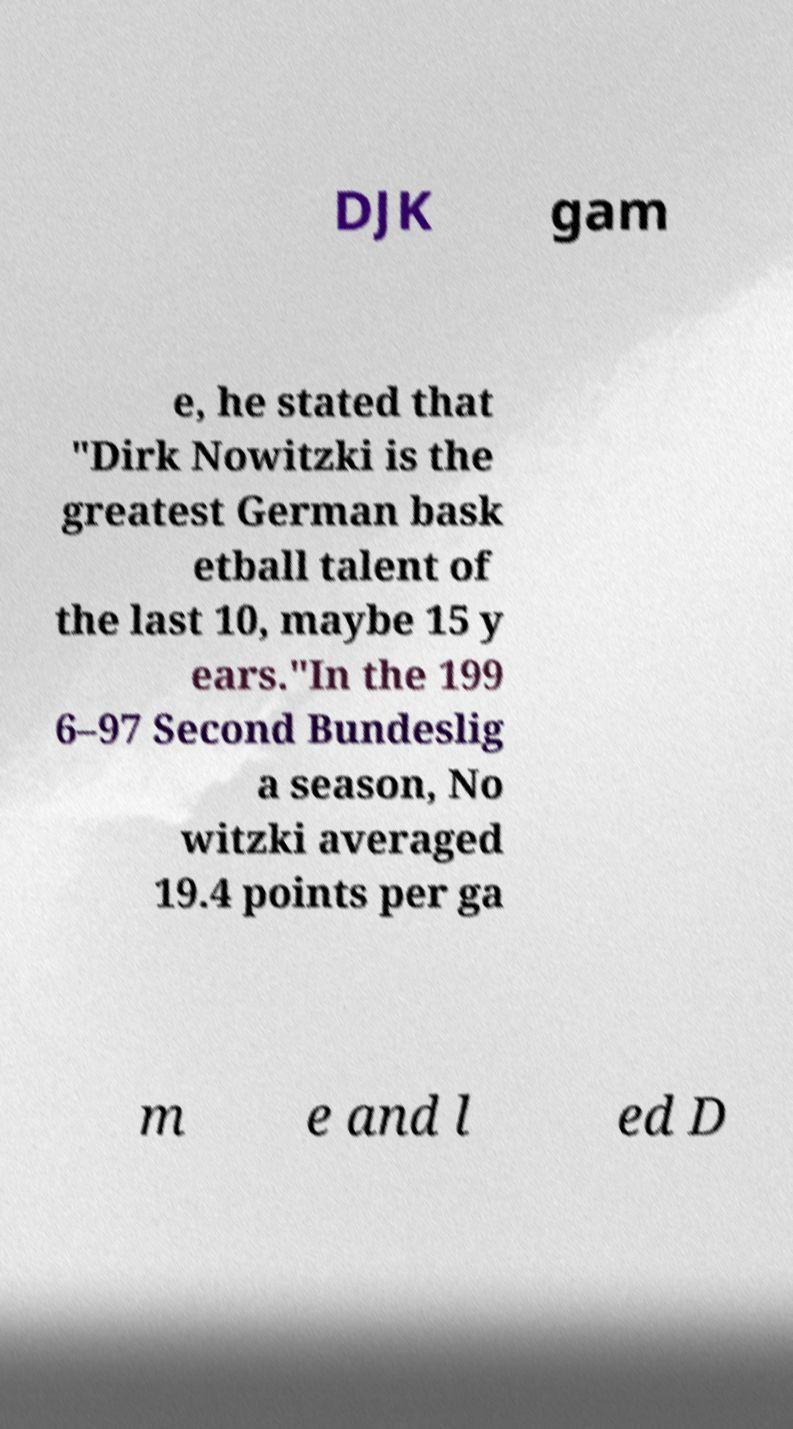I need the written content from this picture converted into text. Can you do that? DJK gam e, he stated that "Dirk Nowitzki is the greatest German bask etball talent of the last 10, maybe 15 y ears."In the 199 6–97 Second Bundeslig a season, No witzki averaged 19.4 points per ga m e and l ed D 